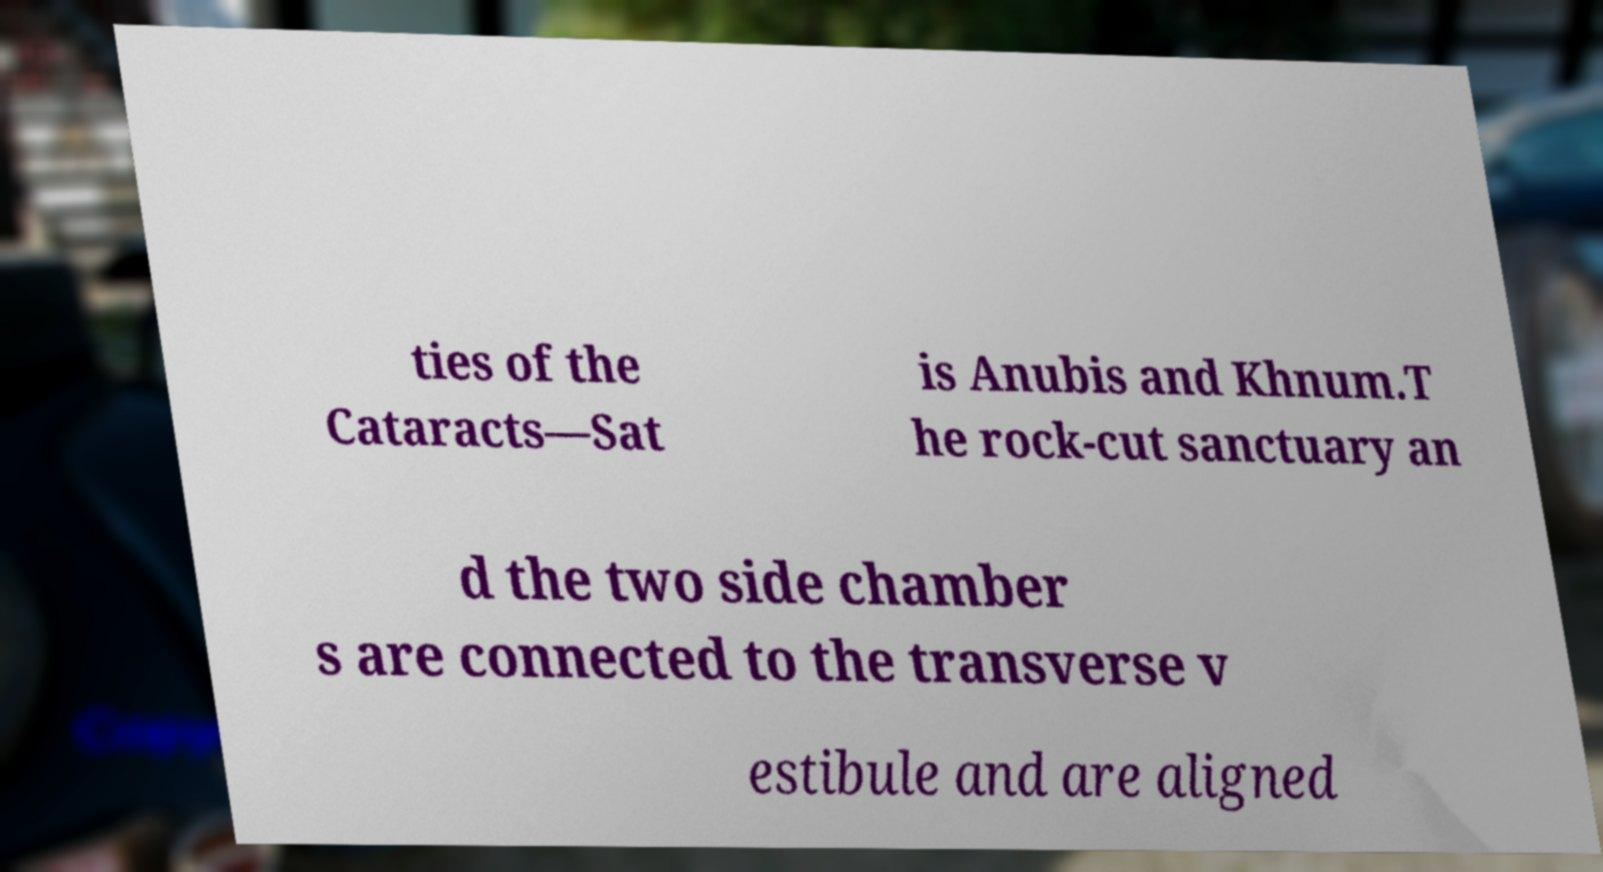Could you assist in decoding the text presented in this image and type it out clearly? ties of the Cataracts—Sat is Anubis and Khnum.T he rock-cut sanctuary an d the two side chamber s are connected to the transverse v estibule and are aligned 